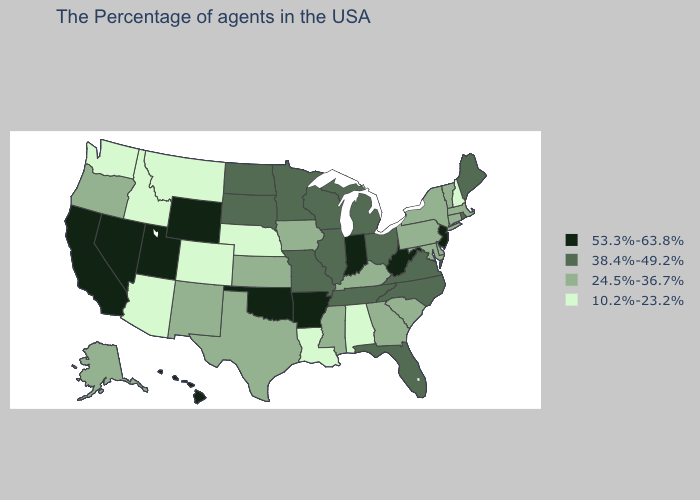Name the states that have a value in the range 38.4%-49.2%?
Keep it brief. Maine, Rhode Island, Virginia, North Carolina, Ohio, Florida, Michigan, Tennessee, Wisconsin, Illinois, Missouri, Minnesota, South Dakota, North Dakota. Which states have the lowest value in the USA?
Write a very short answer. New Hampshire, Alabama, Louisiana, Nebraska, Colorado, Montana, Arizona, Idaho, Washington. What is the value of California?
Short answer required. 53.3%-63.8%. Name the states that have a value in the range 10.2%-23.2%?
Write a very short answer. New Hampshire, Alabama, Louisiana, Nebraska, Colorado, Montana, Arizona, Idaho, Washington. What is the value of Washington?
Write a very short answer. 10.2%-23.2%. Does North Carolina have a lower value than Maryland?
Answer briefly. No. Name the states that have a value in the range 24.5%-36.7%?
Concise answer only. Massachusetts, Vermont, Connecticut, New York, Delaware, Maryland, Pennsylvania, South Carolina, Georgia, Kentucky, Mississippi, Iowa, Kansas, Texas, New Mexico, Oregon, Alaska. Which states have the highest value in the USA?
Write a very short answer. New Jersey, West Virginia, Indiana, Arkansas, Oklahoma, Wyoming, Utah, Nevada, California, Hawaii. Name the states that have a value in the range 38.4%-49.2%?
Short answer required. Maine, Rhode Island, Virginia, North Carolina, Ohio, Florida, Michigan, Tennessee, Wisconsin, Illinois, Missouri, Minnesota, South Dakota, North Dakota. Among the states that border Washington , does Oregon have the highest value?
Be succinct. Yes. Does Wisconsin have a higher value than Maine?
Be succinct. No. Does Massachusetts have the lowest value in the Northeast?
Be succinct. No. Which states hav the highest value in the Northeast?
Answer briefly. New Jersey. Which states have the highest value in the USA?
Answer briefly. New Jersey, West Virginia, Indiana, Arkansas, Oklahoma, Wyoming, Utah, Nevada, California, Hawaii. What is the highest value in states that border Wyoming?
Write a very short answer. 53.3%-63.8%. 